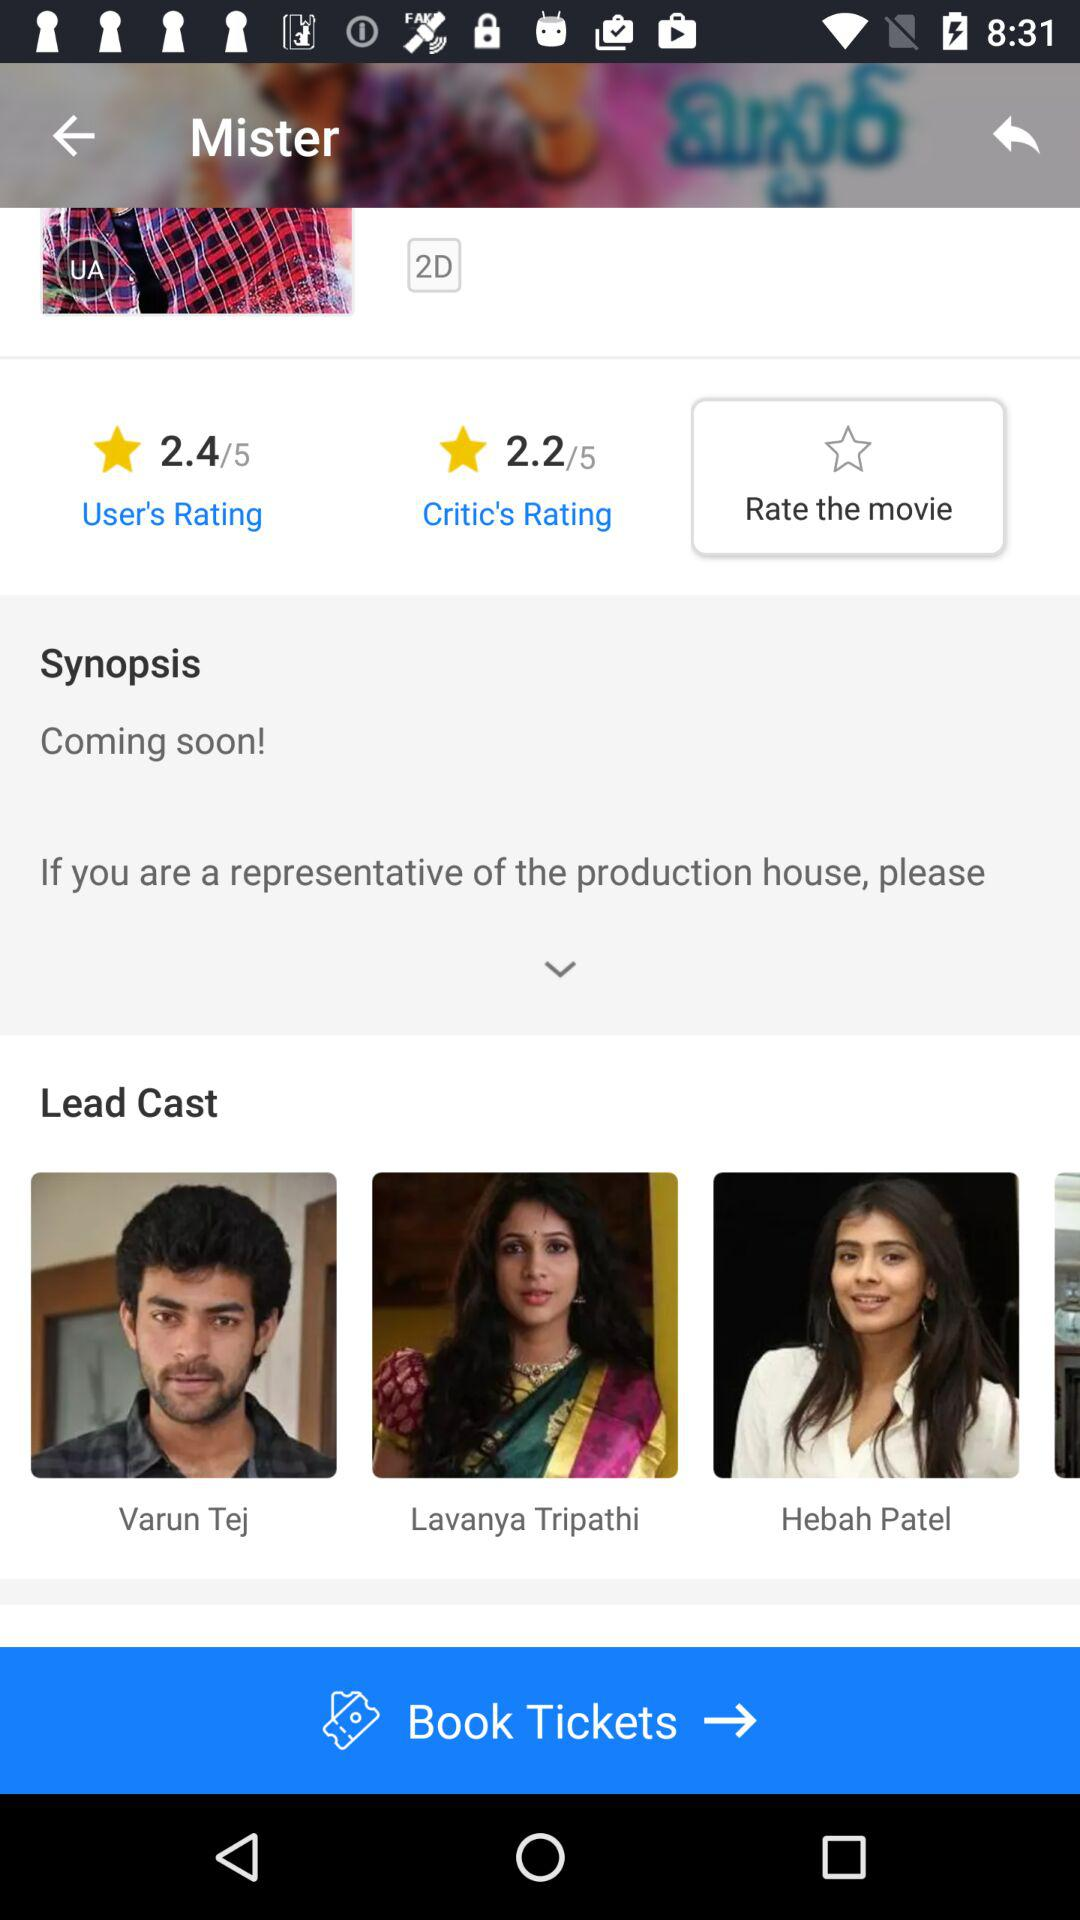What is the name of the lead hero? The name of the lead hero is Varun Tej. 